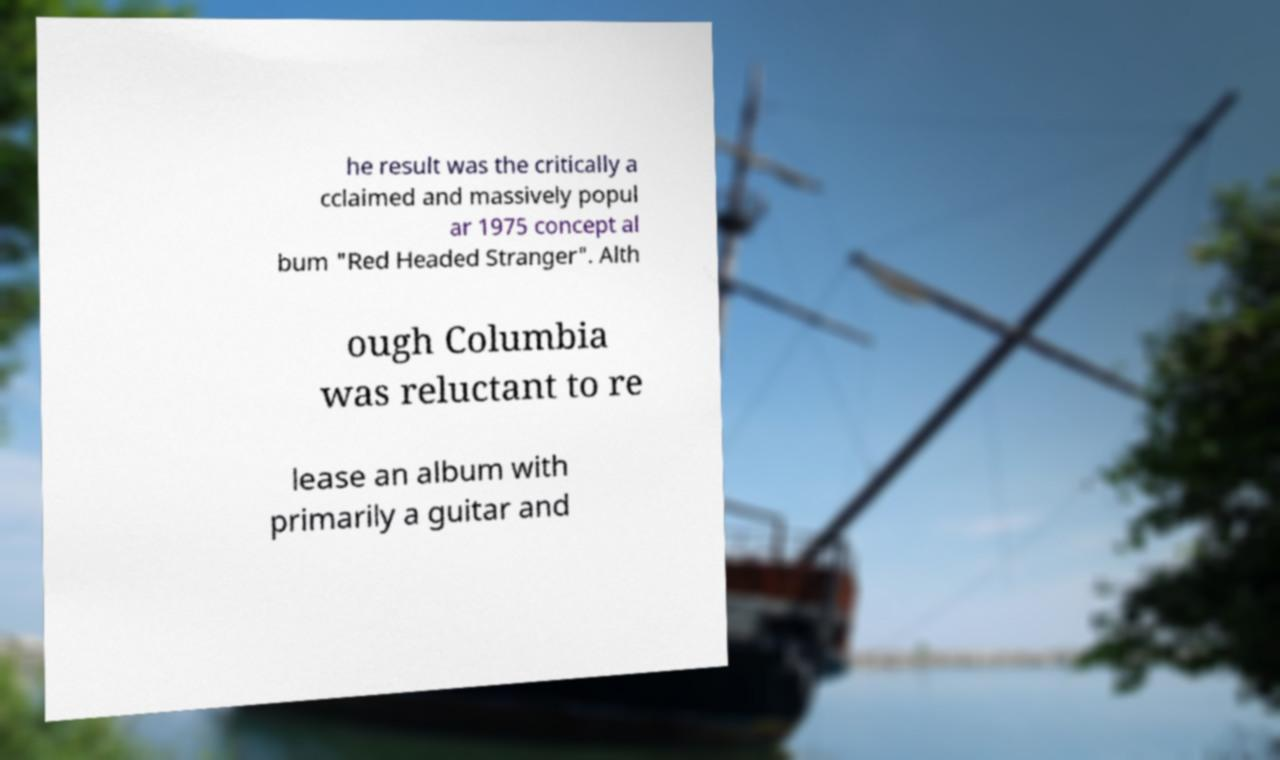Could you extract and type out the text from this image? he result was the critically a cclaimed and massively popul ar 1975 concept al bum "Red Headed Stranger". Alth ough Columbia was reluctant to re lease an album with primarily a guitar and 